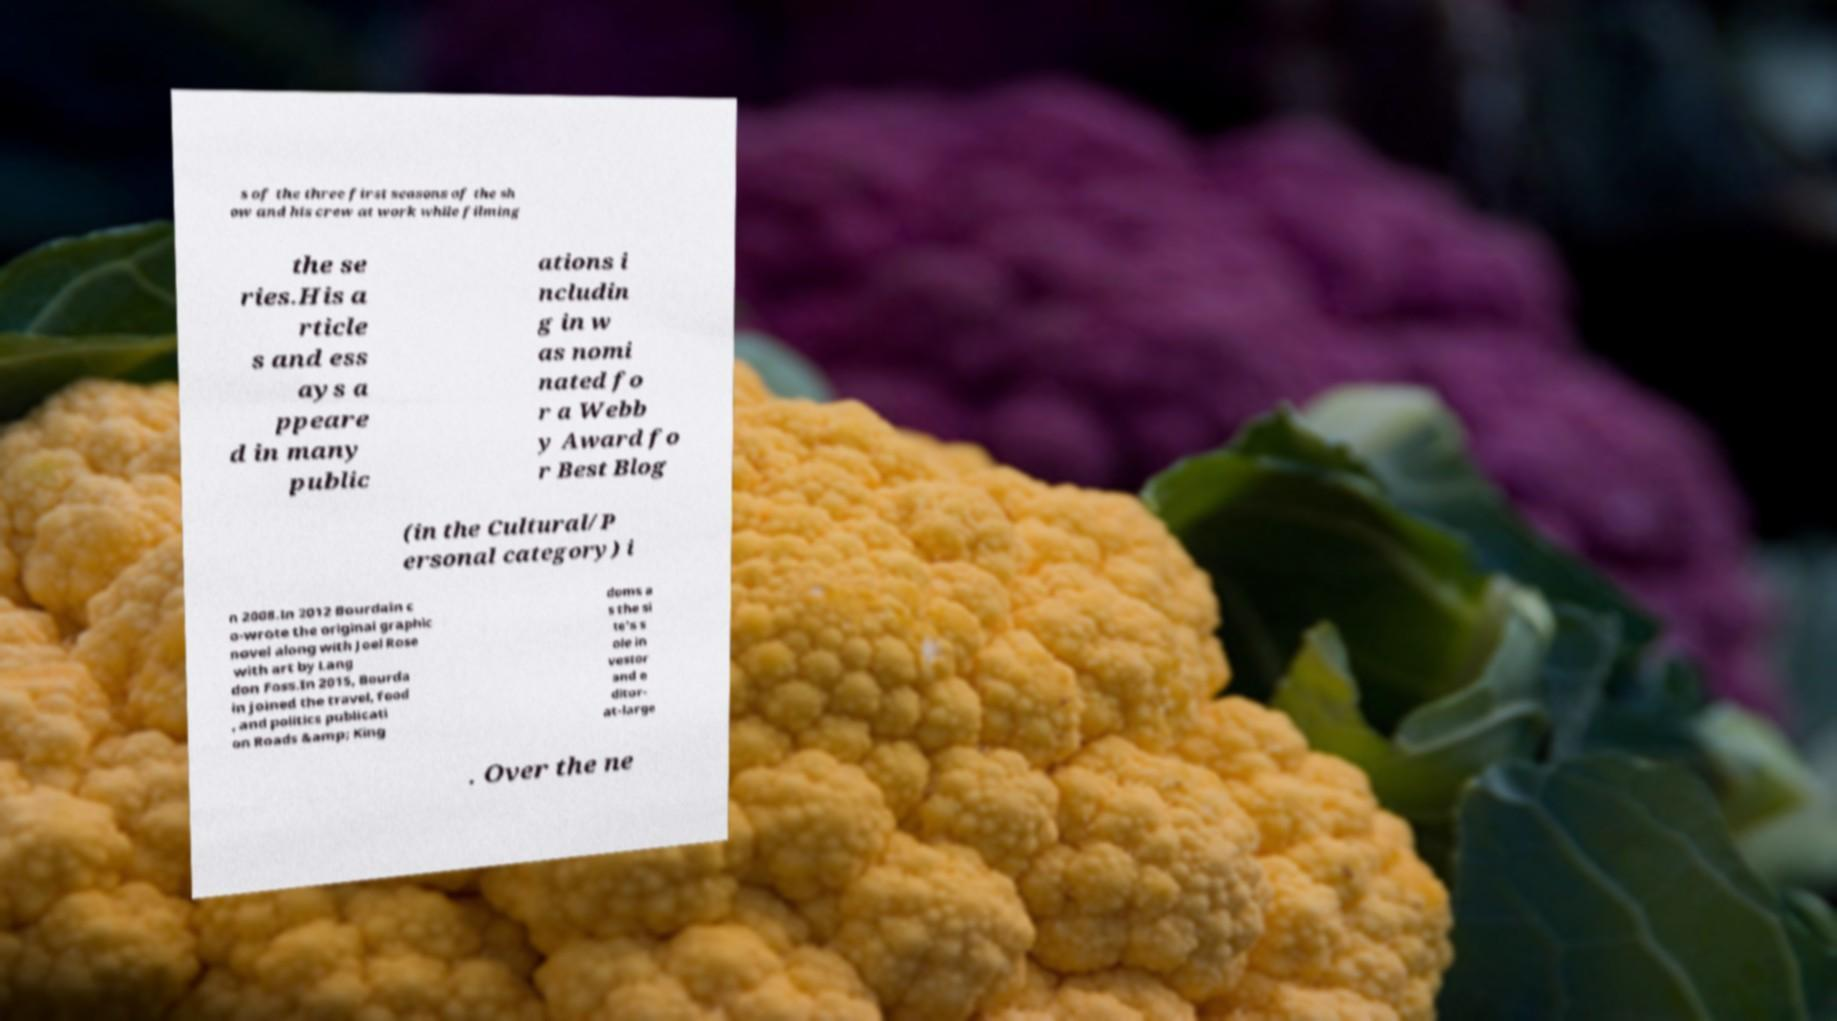For documentation purposes, I need the text within this image transcribed. Could you provide that? s of the three first seasons of the sh ow and his crew at work while filming the se ries.His a rticle s and ess ays a ppeare d in many public ations i ncludin g in w as nomi nated fo r a Webb y Award fo r Best Blog (in the Cultural/P ersonal category) i n 2008.In 2012 Bourdain c o-wrote the original graphic novel along with Joel Rose with art by Lang don Foss.In 2015, Bourda in joined the travel, food , and politics publicati on Roads &amp; King doms a s the si te's s ole in vestor and e ditor- at-large . Over the ne 